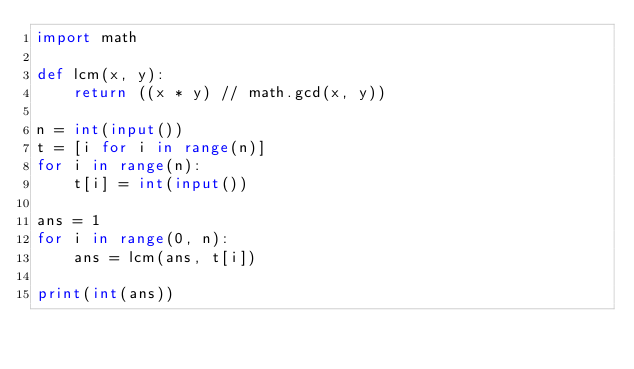<code> <loc_0><loc_0><loc_500><loc_500><_Python_>import math

def lcm(x, y):
    return ((x * y) // math.gcd(x, y))

n = int(input())
t = [i for i in range(n)]
for i in range(n):
    t[i] = int(input())

ans = 1
for i in range(0, n):
    ans = lcm(ans, t[i])

print(int(ans))</code> 